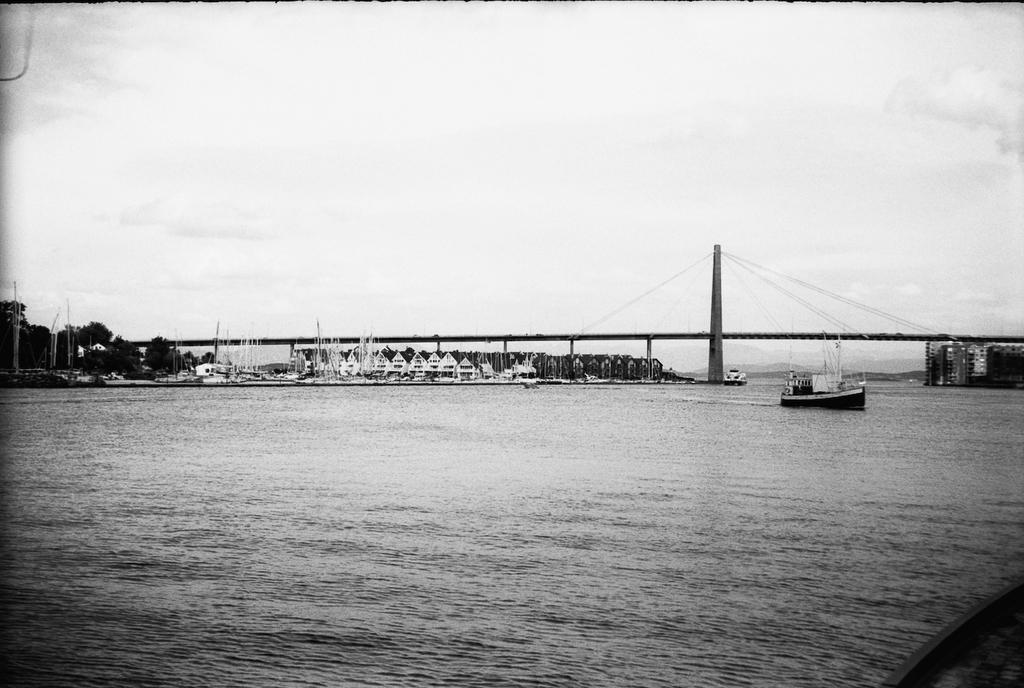In one or two sentences, can you explain what this image depicts? This is a black and white image and here we can see a bridge, pillar, poles, trees and buildings and we can see a boat. At the bottom, there is water and at the top, there is sky. 